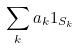<formula> <loc_0><loc_0><loc_500><loc_500>\sum _ { k } a _ { k } 1 _ { S _ { k } }</formula> 